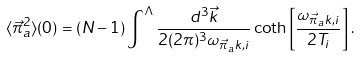<formula> <loc_0><loc_0><loc_500><loc_500>\langle { \vec { \pi } } _ { a } ^ { 2 } \rangle ( 0 ) = ( N - 1 ) \int ^ { \Lambda } \frac { d ^ { 3 } { \vec { k } } } { 2 ( 2 \pi ) ^ { 3 } \omega _ { { \vec { \pi } } _ { a } k , i } } \coth \left [ \frac { \omega _ { { \vec { \pi } } _ { a } k , i } } { 2 T _ { i } } \right ] .</formula> 